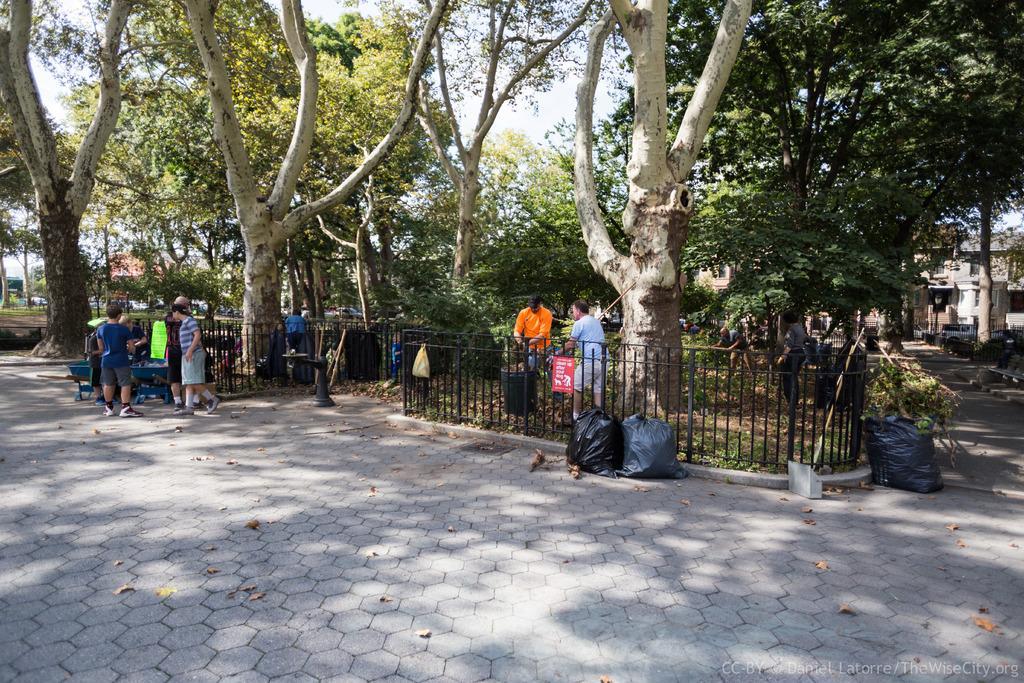Describe this image in one or two sentences. This is an outside view. At the bottom of the image I can see the road. In the background there are many trees. Beside the road there is raining and I can see few people are standing and also few black color bags are placed on the ground. On the right side, I can see a building. 